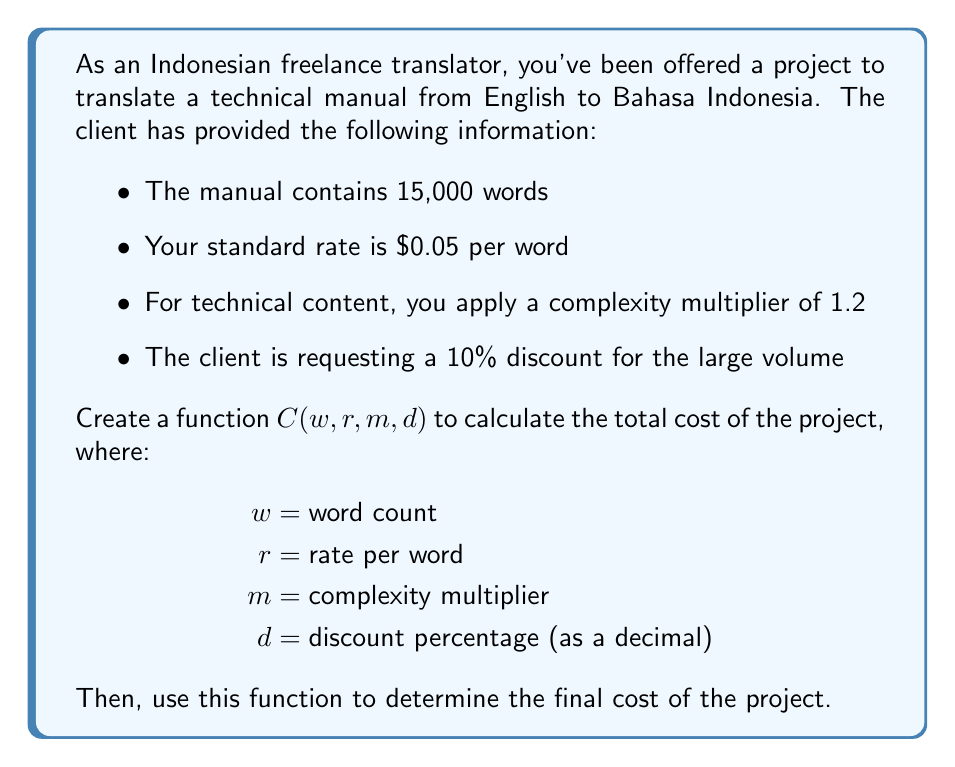Give your solution to this math problem. To solve this problem, we'll follow these steps:

1. Create the function $C(w, r, m, d)$:
   The function should calculate the base cost (words × rate), apply the complexity multiplier, and then subtract the discount.

   $$C(w, r, m, d) = w \times r \times m \times (1 - d)$$

2. Plug in the given values:
   $w = 15,000$ (words)
   $r = 0.05$ (dollars per word)
   $m = 1.2$ (complexity multiplier)
   $d = 0.10$ (10% discount as a decimal)

3. Calculate the final cost:
   $$\begin{align*}
   C(15000, 0.05, 1.2, 0.10) &= 15000 \times 0.05 \times 1.2 \times (1 - 0.10) \\
   &= 15000 \times 0.05 \times 1.2 \times 0.90 \\
   &= 750 \times 1.2 \times 0.90 \\
   &= 900 \times 0.90 \\
   &= 810
   \end{align*}$$

The final cost of the project is $810.
Answer: $810 